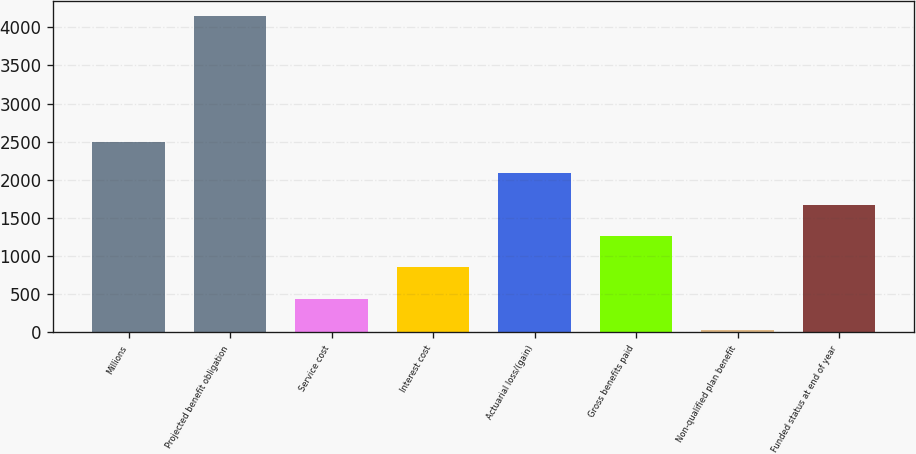<chart> <loc_0><loc_0><loc_500><loc_500><bar_chart><fcel>Millions<fcel>Projected benefit obligation<fcel>Service cost<fcel>Interest cost<fcel>Actuarial loss/(gain)<fcel>Gross benefits paid<fcel>Non-qualified plan benefit<fcel>Funded status at end of year<nl><fcel>2498.4<fcel>4142<fcel>443.9<fcel>854.8<fcel>2087.5<fcel>1265.7<fcel>33<fcel>1676.6<nl></chart> 